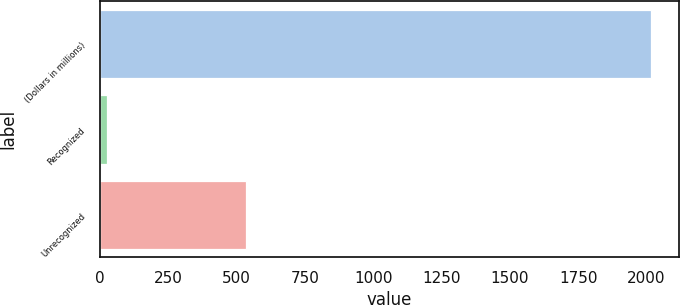<chart> <loc_0><loc_0><loc_500><loc_500><bar_chart><fcel>(Dollars in millions)<fcel>Recognized<fcel>Unrecognized<nl><fcel>2016<fcel>27<fcel>536<nl></chart> 